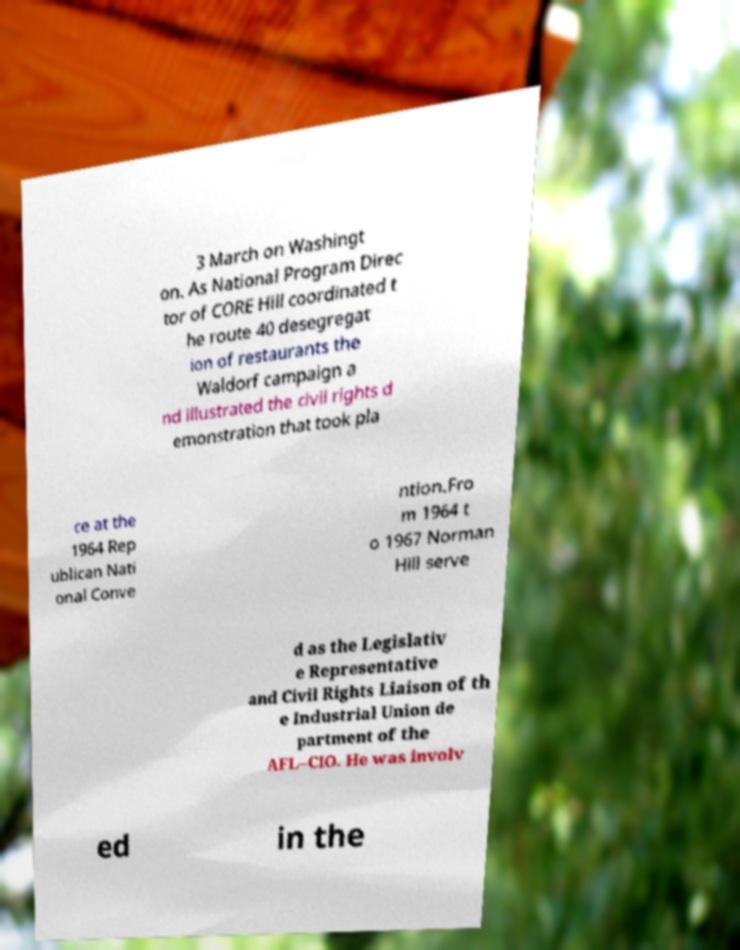What messages or text are displayed in this image? I need them in a readable, typed format. 3 March on Washingt on. As National Program Direc tor of CORE Hill coordinated t he route 40 desegregat ion of restaurants the Waldorf campaign a nd illustrated the civil rights d emonstration that took pla ce at the 1964 Rep ublican Nati onal Conve ntion.Fro m 1964 t o 1967 Norman Hill serve d as the Legislativ e Representative and Civil Rights Liaison of th e Industrial Union de partment of the AFL–CIO. He was involv ed in the 